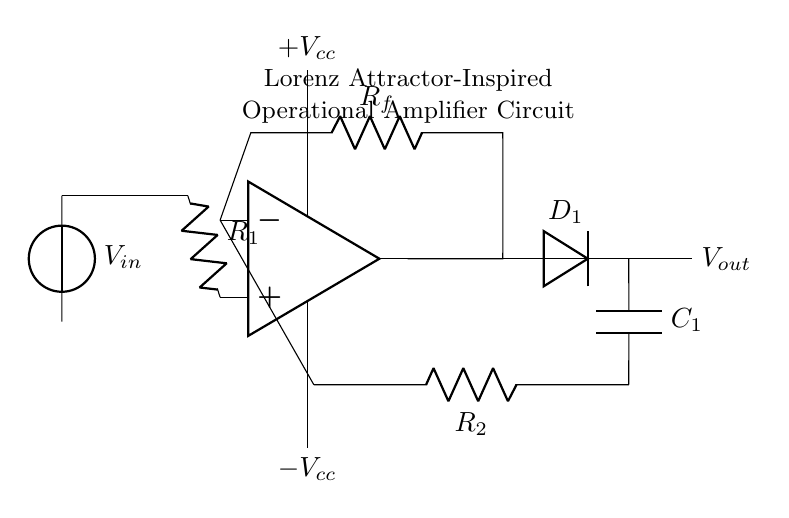what type of diode is used in the circuit? The circuit diagram specifies a diode labeled as D1, indicating a general-purpose diode. The presence of D1 signifies that it is used for rectifying or preventing reverse currents.
Answer: general-purpose diode what is the function of resistor R1? Resistor R1 is connected to the non-inverting input of the operational amplifier, which helps set the gain and control the input impedance of the circuit. Its primary role is to contribute to the amplification process.
Answer: setting gain how does the feedback loop impact the output voltage? The feedback loop, composed of resistor R_f and the diode D1, influences the output voltage by determining how much of the output is fed back into the inverting input. This negative feedback stabilizes the output and creates conditions for chaotic behavior akin to the Lorenz attractor.
Answer: stabilizes output what is the role of capacitor C1 in the circuit? Capacitor C1 connects to the output of the op-amp and allows for stabilization and filtering of voltage spikes, while also contributing to the frequency response of the circuit. It plays a crucial role in shaping the circuit's dynamic behavior, contributing to chaos.
Answer: stabilizing voltage what is the overall type of this circuit? The diagram represents an operational amplifier circuit inspired by the Lorenz attractor due to its incorporation of non-linear dynamics through feedback and passive components, aiming to replicate chaotic behavior in electronic form.
Answer: operational amplifier 